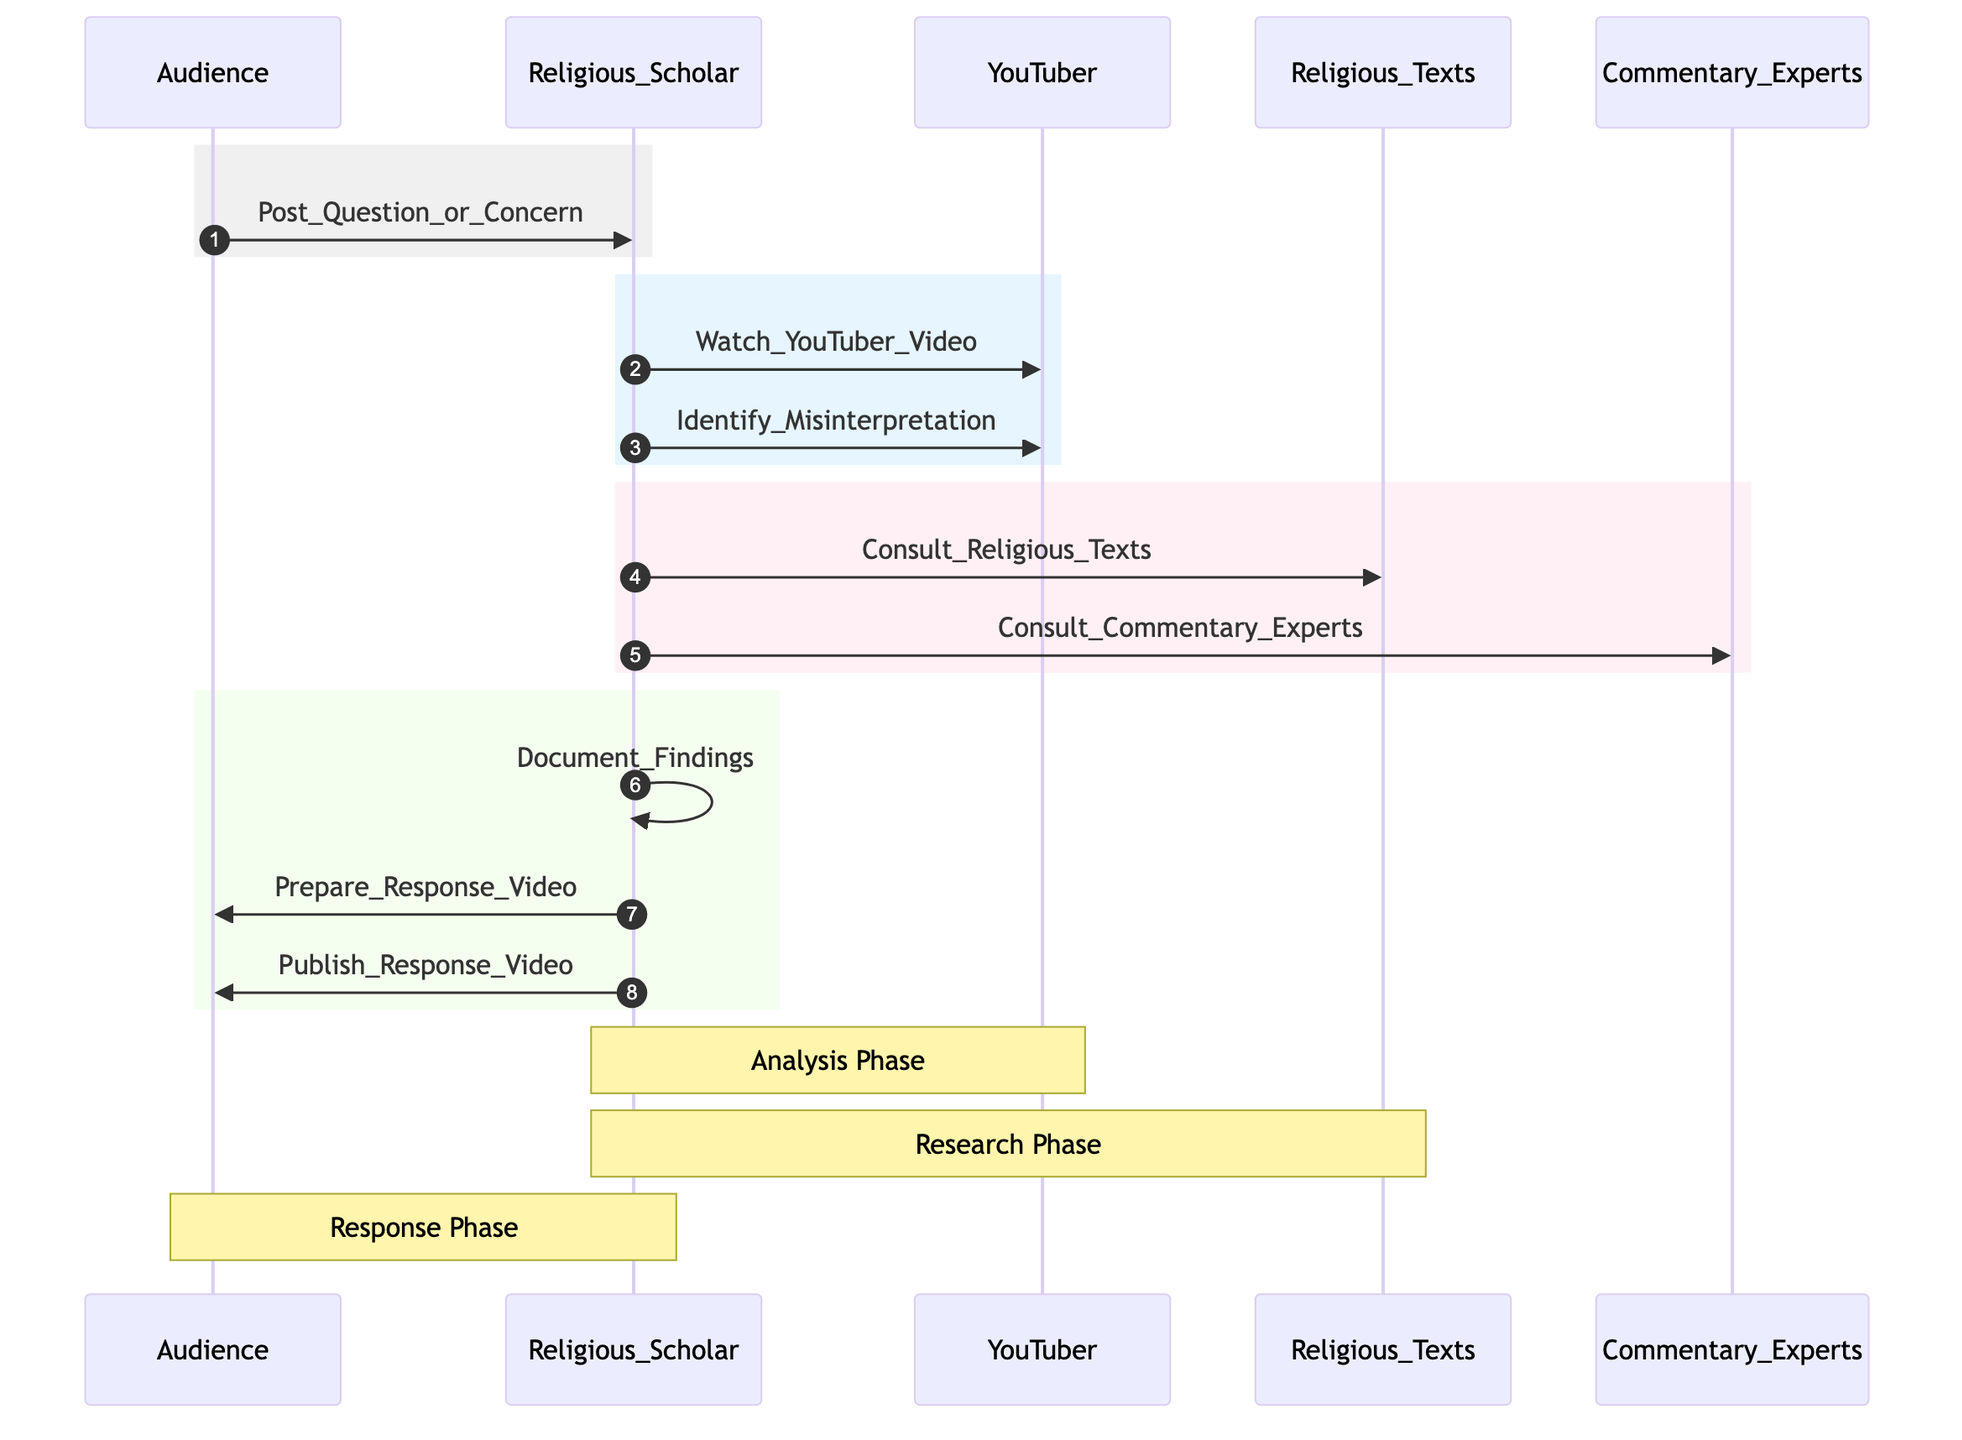What is the first action in the sequence diagram? The sequence diagram starts with the "Audience" actor posting a question or concern to the "Religious Scholar".
Answer: Post Question or Concern How many actors are involved in the sequence diagram? There are five distinct actors: Audience, Religious Scholar, YouTuber, Religious Texts, and Commentary Experts.
Answer: Five What action does the Religious Scholar take after identifying a misinterpretation? After identifying a misinterpretation, the "Religious Scholar" consults "Religious Texts" and "Commentary Experts".
Answer: Consult Religious Texts, Consult Commentary Experts During which phase does the Religious Scholar document their findings? Documenting findings occurs during the "Research Phase".
Answer: Research Phase What is the final action taken by the Religious Scholar in the diagram? The final action is "Publish Response Video" directed towards the Audience.
Answer: Publish Response Video Why does the Religious Scholar watch the YouTuber's video? The action of watching the YouTuber's video is necessary to gather information to identify misinterpretations.
Answer: To identify misinterpretation How many actions does the Religious Scholar take after posting the question or concern? The Religious Scholar takes five actions after the initial question or concern is posted: watching the video, identifying misinterpretation, consulting religious texts, consulting commentary experts, and documenting findings.
Answer: Five What notation type is used to mark the different phases in the diagram? The notation used for marking different phases is "note".
Answer: Note Which actor is directly responsible for addressing the audience's concerns in the diagram? The "Religious Scholar" is responsible for addressing the audience's concerns through documentation and response video preparation.
Answer: Religious Scholar 